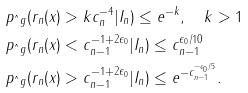Convert formula to latex. <formula><loc_0><loc_0><loc_500><loc_500>& p _ { \hat { \ } g } ( r _ { n } ( x ) > k c _ { n } ^ { - 4 } | I _ { n } ) \leq e ^ { - k } , \quad k > 1 \\ & p _ { \hat { \ } g } ( r _ { n } ( x ) < c _ { n - 1 } ^ { - 1 + 2 \epsilon _ { 0 } } | I _ { n } ) \leq c _ { n - 1 } ^ { \epsilon _ { 0 } / 1 0 } \\ & p _ { \hat { \ } g } ( r _ { n } ( x ) > c _ { n - 1 } ^ { - 1 + 2 \epsilon _ { 0 } } | I _ { n } ) \leq e ^ { - c _ { n - 1 } ^ { - \epsilon _ { 0 } / 5 } } .</formula> 